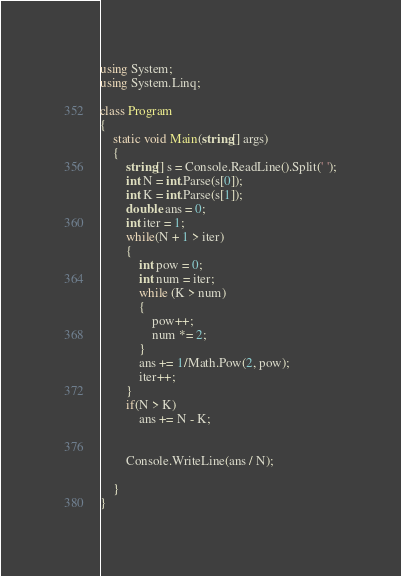Convert code to text. <code><loc_0><loc_0><loc_500><loc_500><_C#_>using System;
using System.Linq;

class Program
{
    static void Main(string[] args)
    {
        string[] s = Console.ReadLine().Split(' ');
        int N = int.Parse(s[0]);
        int K = int.Parse(s[1]);
        double ans = 0;
        int iter = 1;
        while(N + 1 > iter)
        {
            int pow = 0;
            int num = iter;
            while (K > num)
            {
                pow++;
                num *= 2;
            }
            ans += 1/Math.Pow(2, pow);
            iter++;
        }
        if(N > K)
            ans += N - K;


        Console.WriteLine(ans / N);
    
    }
}
</code> 